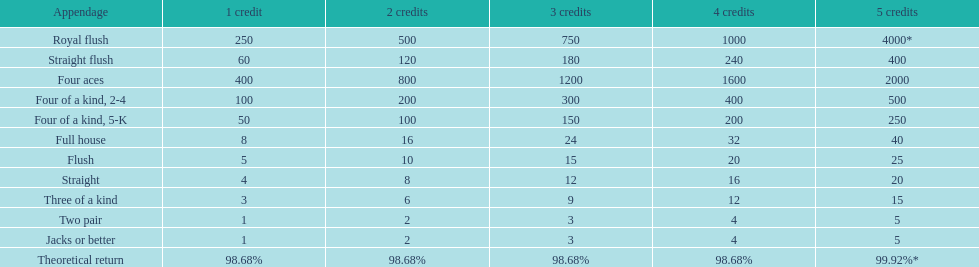What is the difference of payout on 3 credits, between a straight flush and royal flush? 570. 